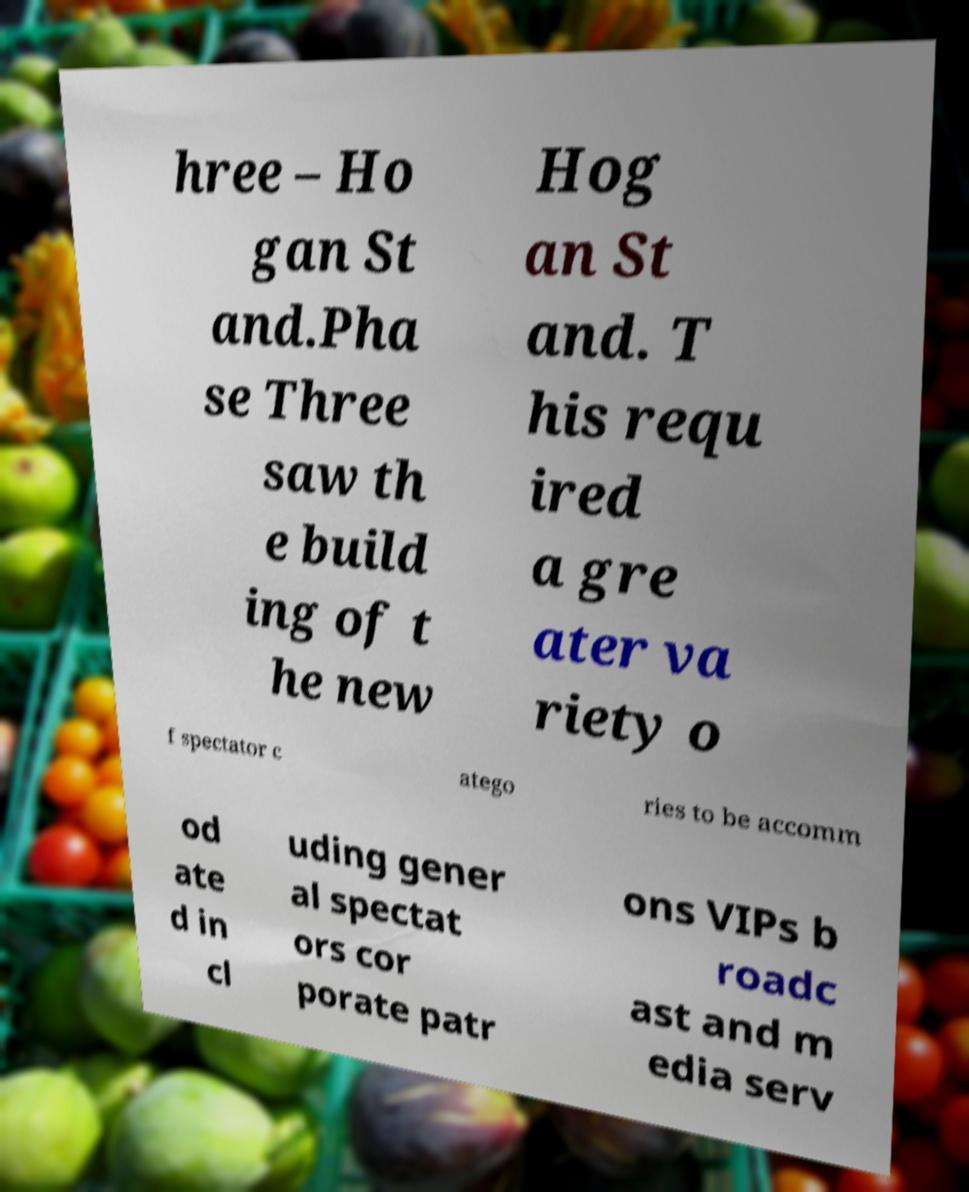For documentation purposes, I need the text within this image transcribed. Could you provide that? hree – Ho gan St and.Pha se Three saw th e build ing of t he new Hog an St and. T his requ ired a gre ater va riety o f spectator c atego ries to be accomm od ate d in cl uding gener al spectat ors cor porate patr ons VIPs b roadc ast and m edia serv 